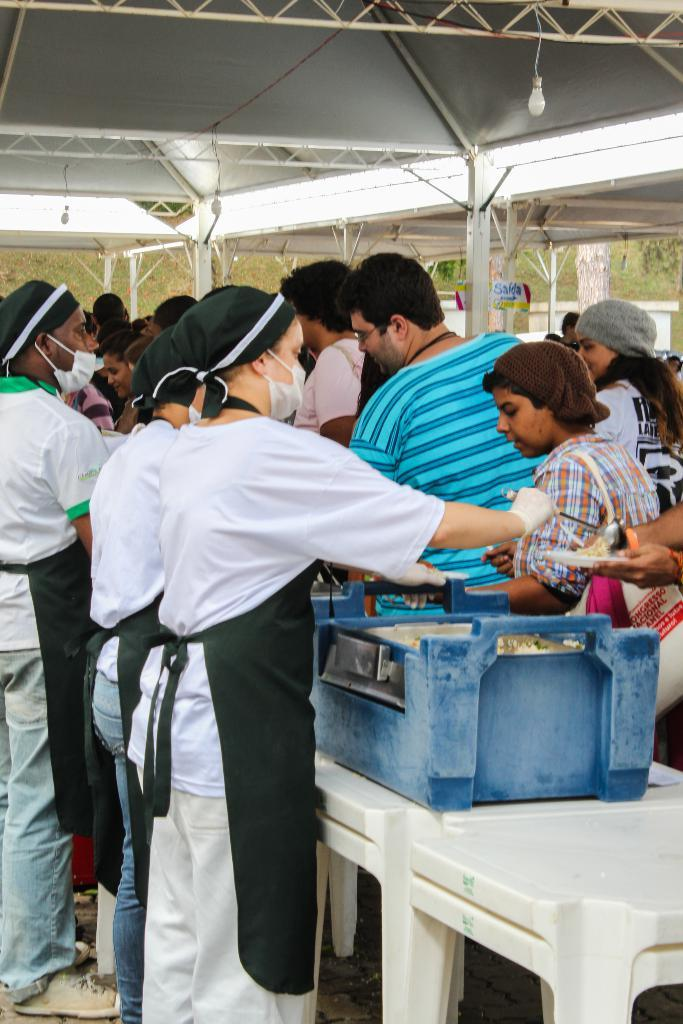How many people are in the image? There is a group of people in the image. What are the people doing in the image? The people are standing. What are the people wearing on their faces in the image? The people are wearing masks. What can be seen in the background of the image? There are pillars and light visible in the background of the image. What type of land can be seen in the image? There is no land visible in the image; it features a group of people standing and wearing masks, with pillars and light in the background. Can you describe the action of the dog in the image? There is no dog present in the image. 